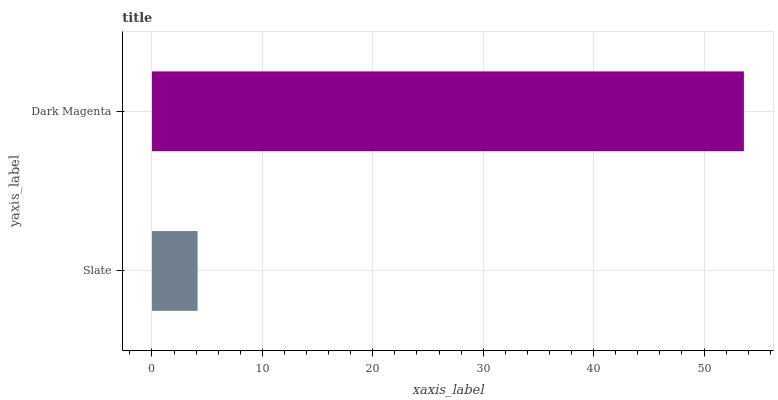Is Slate the minimum?
Answer yes or no. Yes. Is Dark Magenta the maximum?
Answer yes or no. Yes. Is Dark Magenta the minimum?
Answer yes or no. No. Is Dark Magenta greater than Slate?
Answer yes or no. Yes. Is Slate less than Dark Magenta?
Answer yes or no. Yes. Is Slate greater than Dark Magenta?
Answer yes or no. No. Is Dark Magenta less than Slate?
Answer yes or no. No. Is Dark Magenta the high median?
Answer yes or no. Yes. Is Slate the low median?
Answer yes or no. Yes. Is Slate the high median?
Answer yes or no. No. Is Dark Magenta the low median?
Answer yes or no. No. 